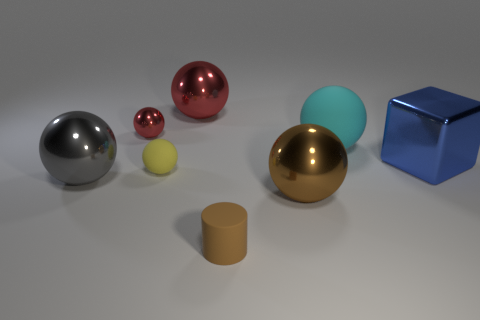What number of other things are there of the same size as the gray object?
Your answer should be compact. 4. Do the tiny yellow object and the brown thing that is on the right side of the tiny brown rubber thing have the same shape?
Your response must be concise. Yes. Are there the same number of large metallic objects in front of the brown matte thing and tiny yellow balls that are on the right side of the tiny yellow matte thing?
Your answer should be compact. Yes. Is the color of the tiny shiny sphere on the left side of the brown cylinder the same as the large metallic thing behind the blue block?
Provide a short and direct response. Yes. Is the number of things that are to the right of the big brown shiny thing greater than the number of large yellow blocks?
Ensure brevity in your answer.  Yes. What material is the large red thing?
Your response must be concise. Metal. What is the shape of the big brown object that is made of the same material as the large cube?
Your answer should be compact. Sphere. What size is the yellow ball that is on the right side of the tiny sphere behind the big blue metal thing?
Keep it short and to the point. Small. The large thing in front of the big gray metallic object is what color?
Offer a very short reply. Brown. Is there a small yellow thing that has the same shape as the big cyan object?
Offer a terse response. Yes. 